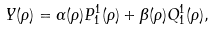<formula> <loc_0><loc_0><loc_500><loc_500>Y ( \rho ) = \alpha ( \rho ) P ^ { 1 } _ { 1 } ( \rho ) + \beta ( \rho ) Q ^ { 1 } _ { 1 } ( \rho ) ,</formula> 